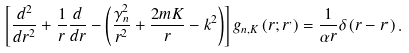<formula> <loc_0><loc_0><loc_500><loc_500>\left [ \frac { d ^ { 2 } } { d r ^ { 2 } } + \frac { 1 } { r } \frac { d } { d r } - \left ( \frac { \gamma _ { n } ^ { 2 } } { r ^ { 2 } } + \frac { 2 m K } { r } - k ^ { 2 } \right ) \right ] g _ { n , K } \left ( r ; r ^ { , } \right ) = \frac { 1 } { \alpha r } \delta \left ( r - r ^ { , } \right ) .</formula> 